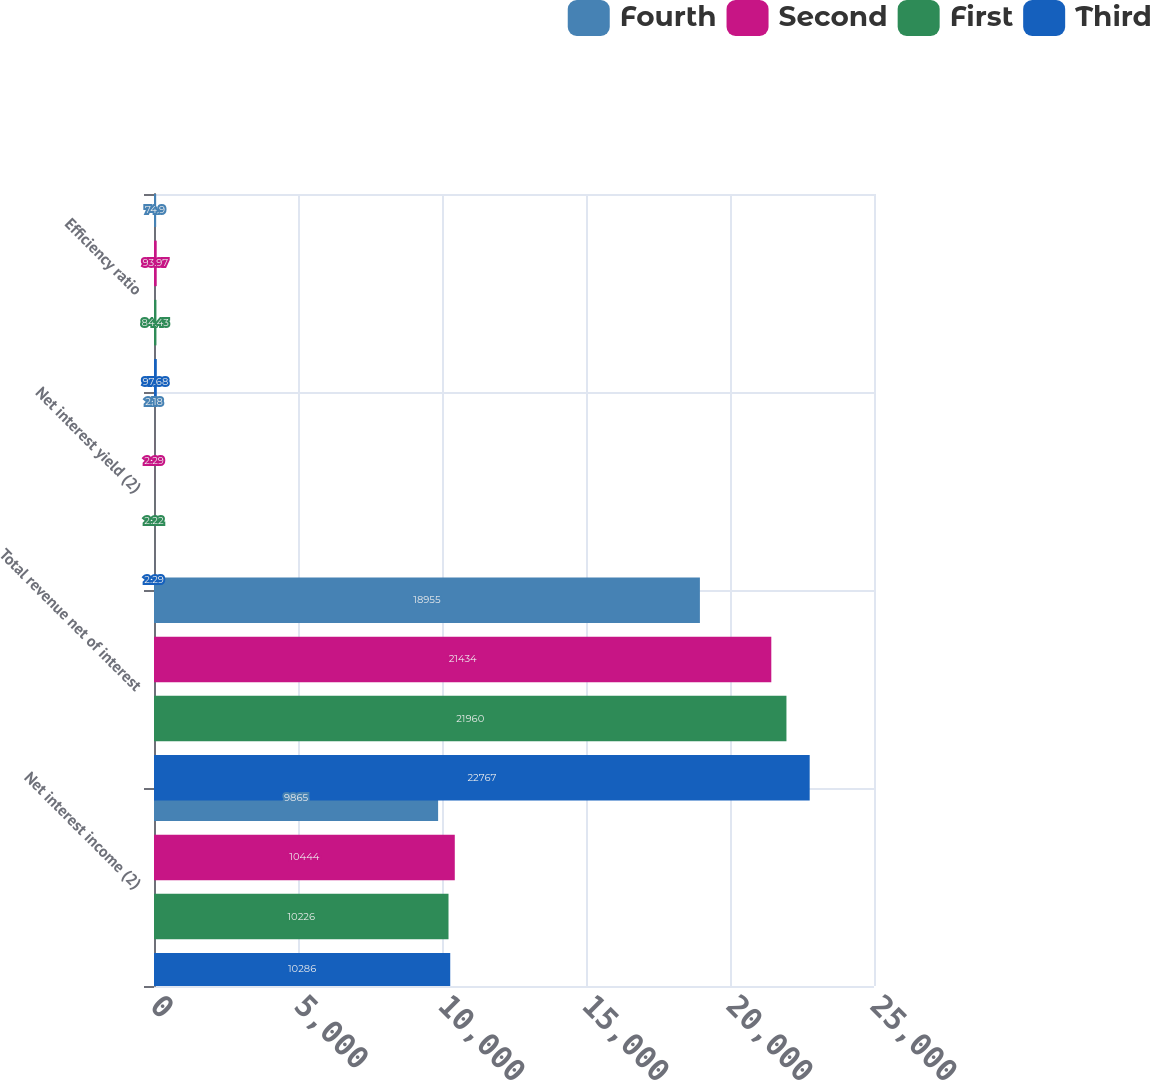Convert chart. <chart><loc_0><loc_0><loc_500><loc_500><stacked_bar_chart><ecel><fcel>Net interest income (2)<fcel>Total revenue net of interest<fcel>Net interest yield (2)<fcel>Efficiency ratio<nl><fcel>Fourth<fcel>9865<fcel>18955<fcel>2.18<fcel>74.9<nl><fcel>Second<fcel>10444<fcel>21434<fcel>2.29<fcel>93.97<nl><fcel>First<fcel>10226<fcel>21960<fcel>2.22<fcel>84.43<nl><fcel>Third<fcel>10286<fcel>22767<fcel>2.29<fcel>97.68<nl></chart> 